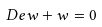<formula> <loc_0><loc_0><loc_500><loc_500>\ D e w + w = 0</formula> 